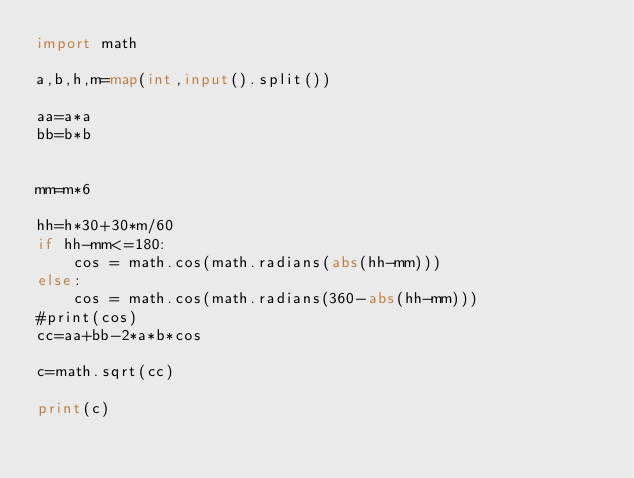<code> <loc_0><loc_0><loc_500><loc_500><_Python_>import math

a,b,h,m=map(int,input().split())

aa=a*a
bb=b*b


mm=m*6

hh=h*30+30*m/60
if hh-mm<=180:
    cos = math.cos(math.radians(abs(hh-mm)))
else:
    cos = math.cos(math.radians(360-abs(hh-mm)))
#print(cos)
cc=aa+bb-2*a*b*cos

c=math.sqrt(cc)

print(c)
</code> 